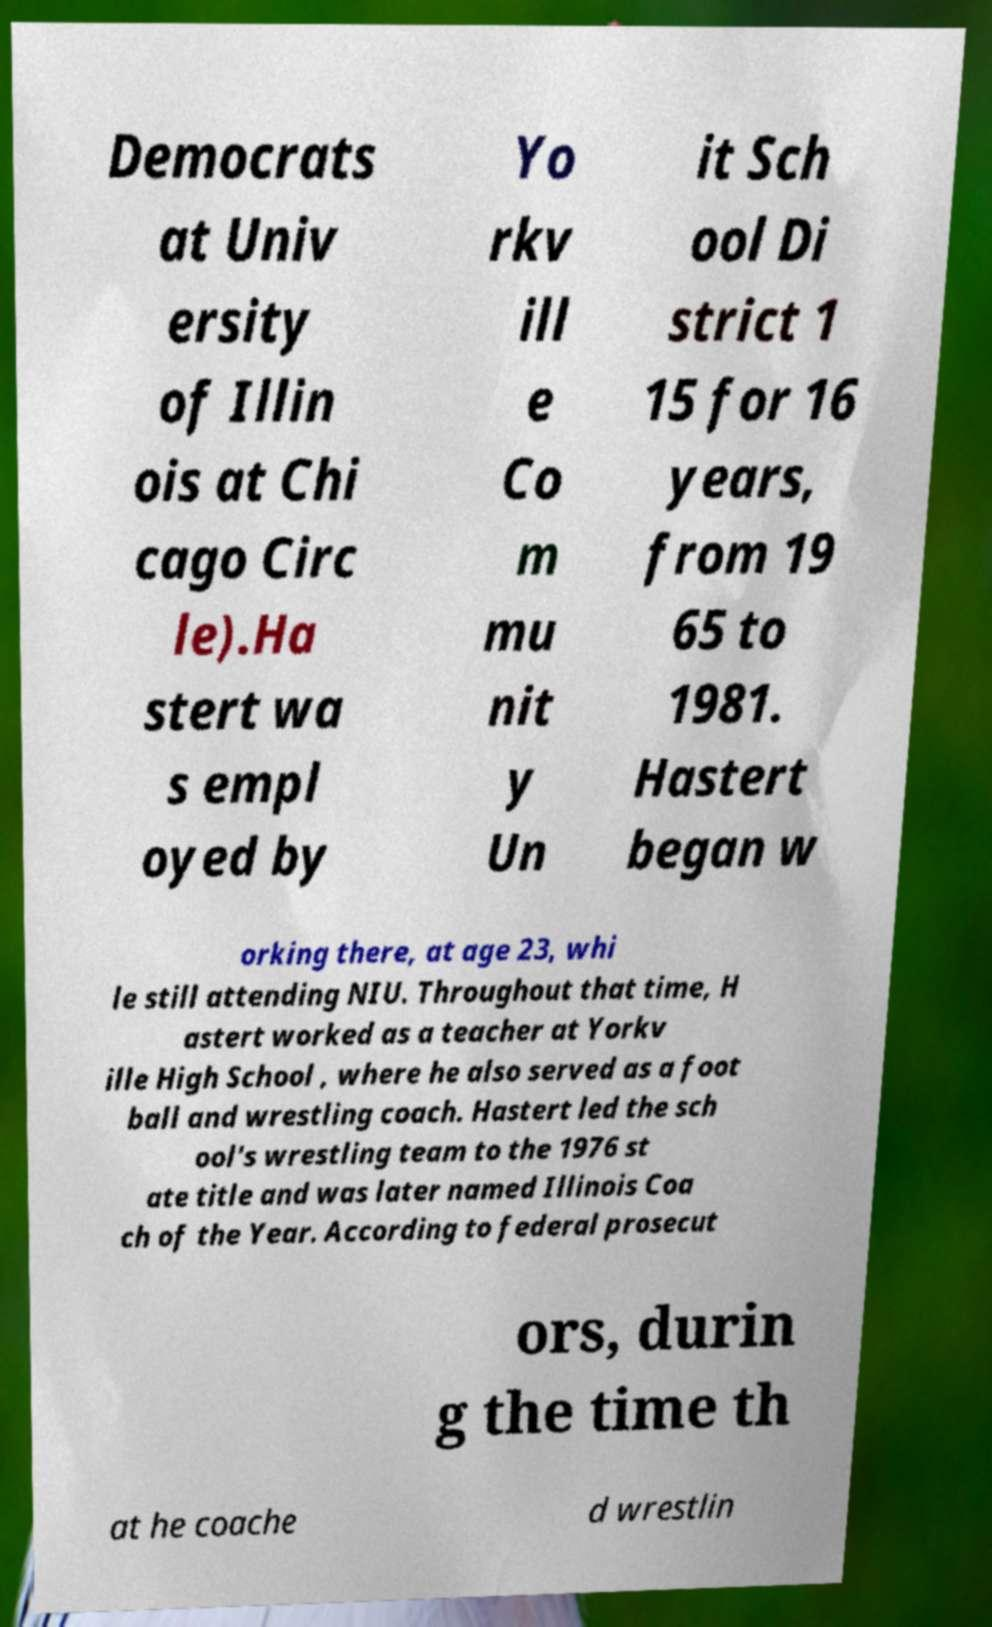For documentation purposes, I need the text within this image transcribed. Could you provide that? Democrats at Univ ersity of Illin ois at Chi cago Circ le).Ha stert wa s empl oyed by Yo rkv ill e Co m mu nit y Un it Sch ool Di strict 1 15 for 16 years, from 19 65 to 1981. Hastert began w orking there, at age 23, whi le still attending NIU. Throughout that time, H astert worked as a teacher at Yorkv ille High School , where he also served as a foot ball and wrestling coach. Hastert led the sch ool's wrestling team to the 1976 st ate title and was later named Illinois Coa ch of the Year. According to federal prosecut ors, durin g the time th at he coache d wrestlin 